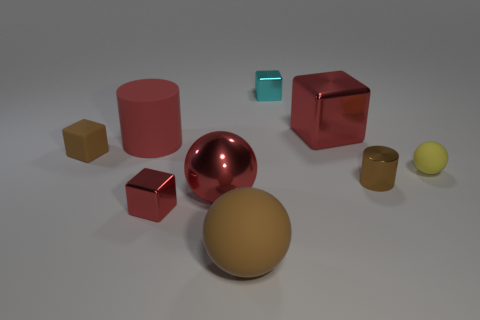Subtract 2 cubes. How many cubes are left? 2 Add 1 tiny cyan rubber objects. How many objects exist? 10 Subtract all blocks. How many objects are left? 5 Subtract 0 cyan spheres. How many objects are left? 9 Subtract all small things. Subtract all red spheres. How many objects are left? 3 Add 9 small red metal blocks. How many small red metal blocks are left? 10 Add 1 blue things. How many blue things exist? 1 